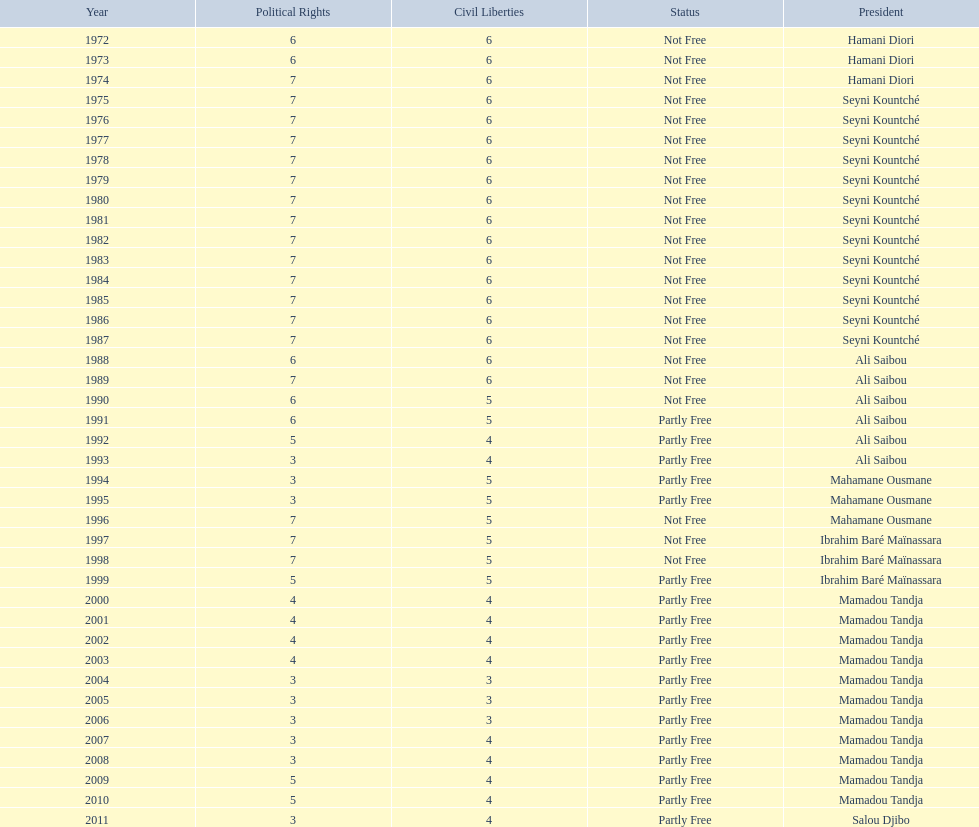Who was president before mamadou tandja? Ibrahim Baré Maïnassara. 